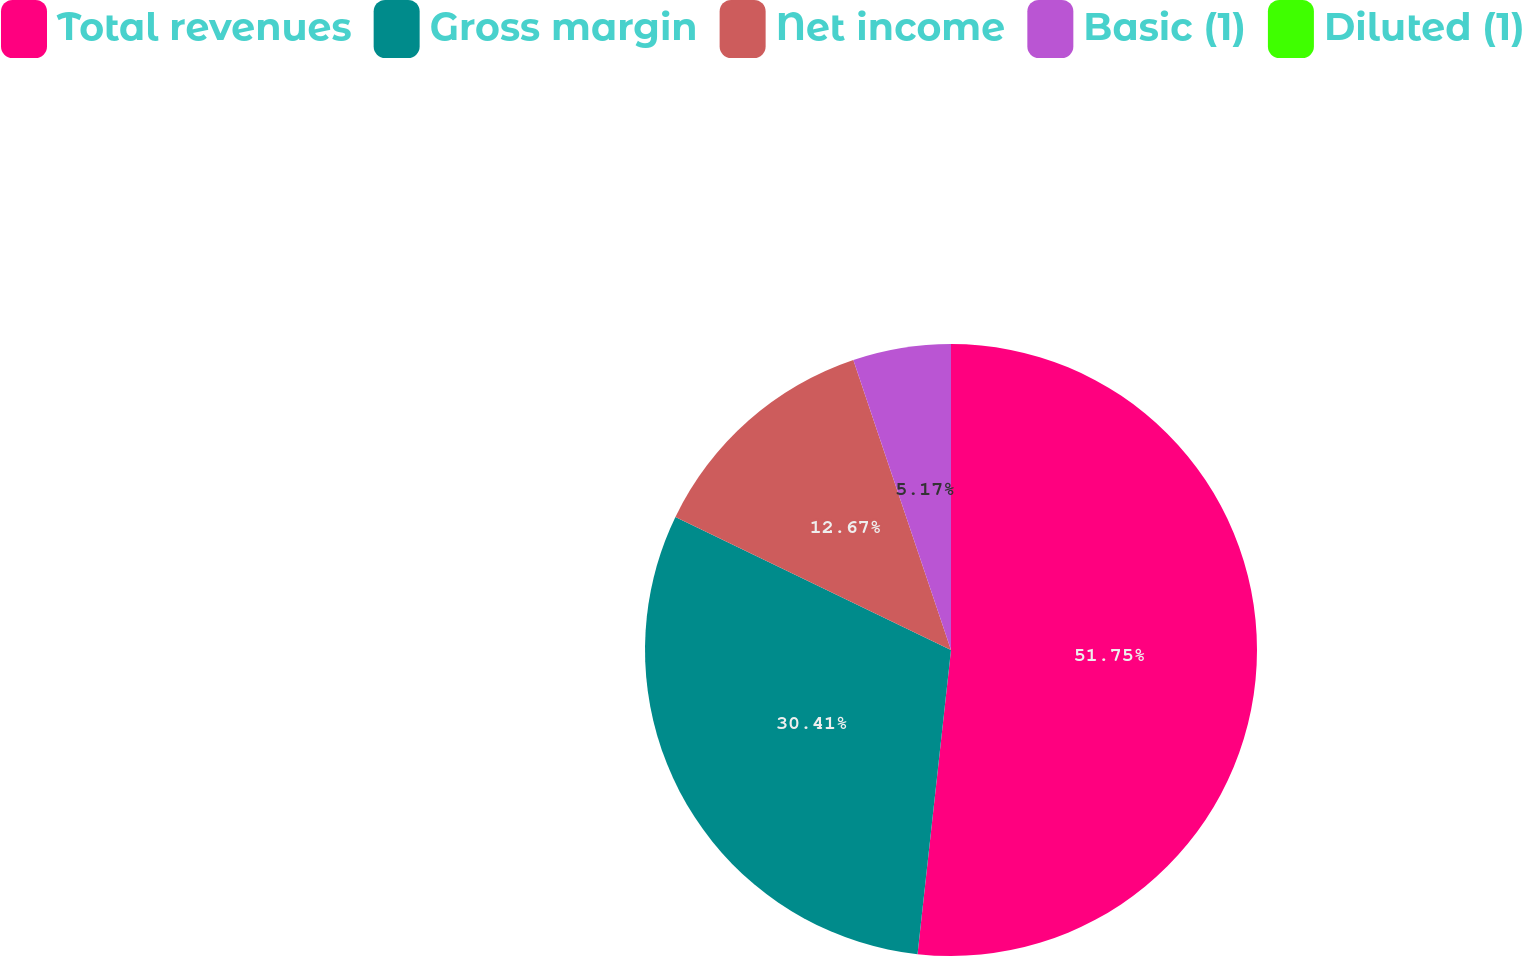Convert chart to OTSL. <chart><loc_0><loc_0><loc_500><loc_500><pie_chart><fcel>Total revenues<fcel>Gross margin<fcel>Net income<fcel>Basic (1)<fcel>Diluted (1)<nl><fcel>51.74%<fcel>30.41%<fcel>12.67%<fcel>5.17%<fcel>0.0%<nl></chart> 